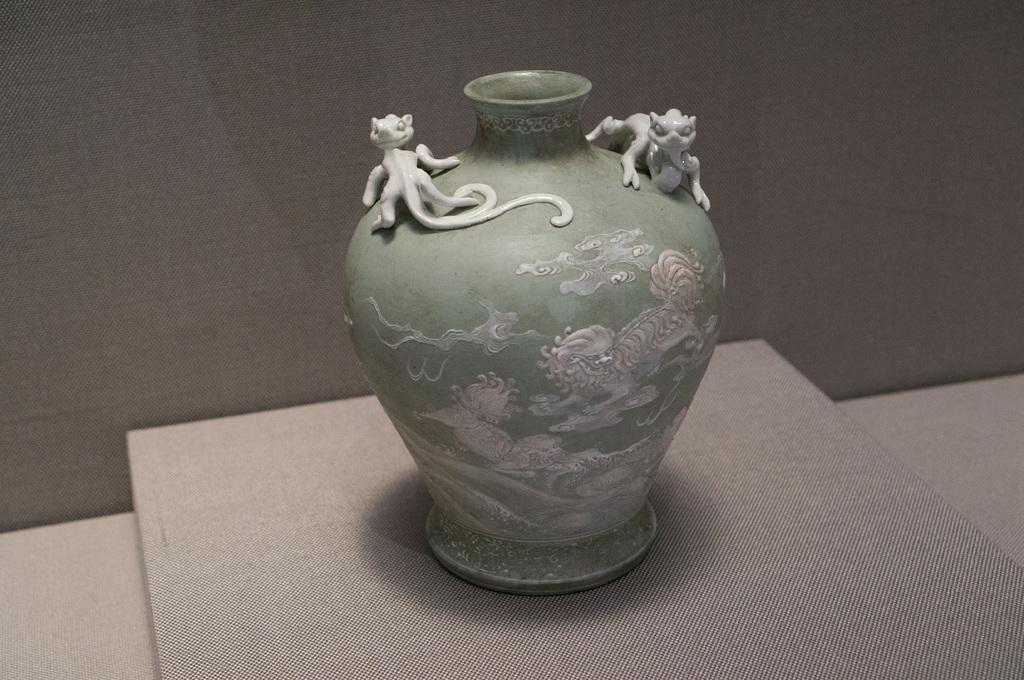How would you summarize this image in a sentence or two? Background portion of the picture is in grey color. In this picture we can see a pot which is designed very beautifully is placed on a platform. 